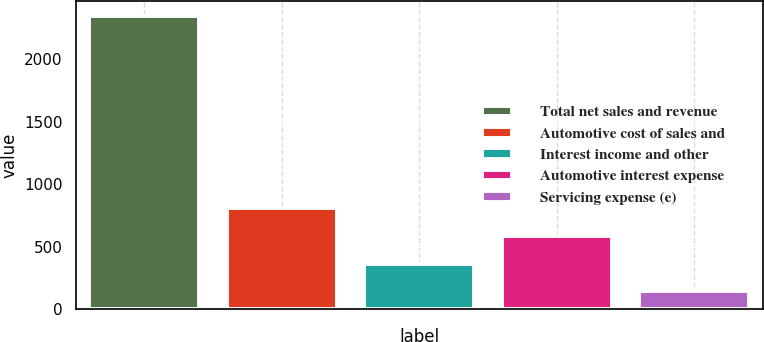Convert chart. <chart><loc_0><loc_0><loc_500><loc_500><bar_chart><fcel>Total net sales and revenue<fcel>Automotive cost of sales and<fcel>Interest income and other<fcel>Automotive interest expense<fcel>Servicing expense (e)<nl><fcel>2350<fcel>805.8<fcel>364.6<fcel>585.2<fcel>144<nl></chart> 